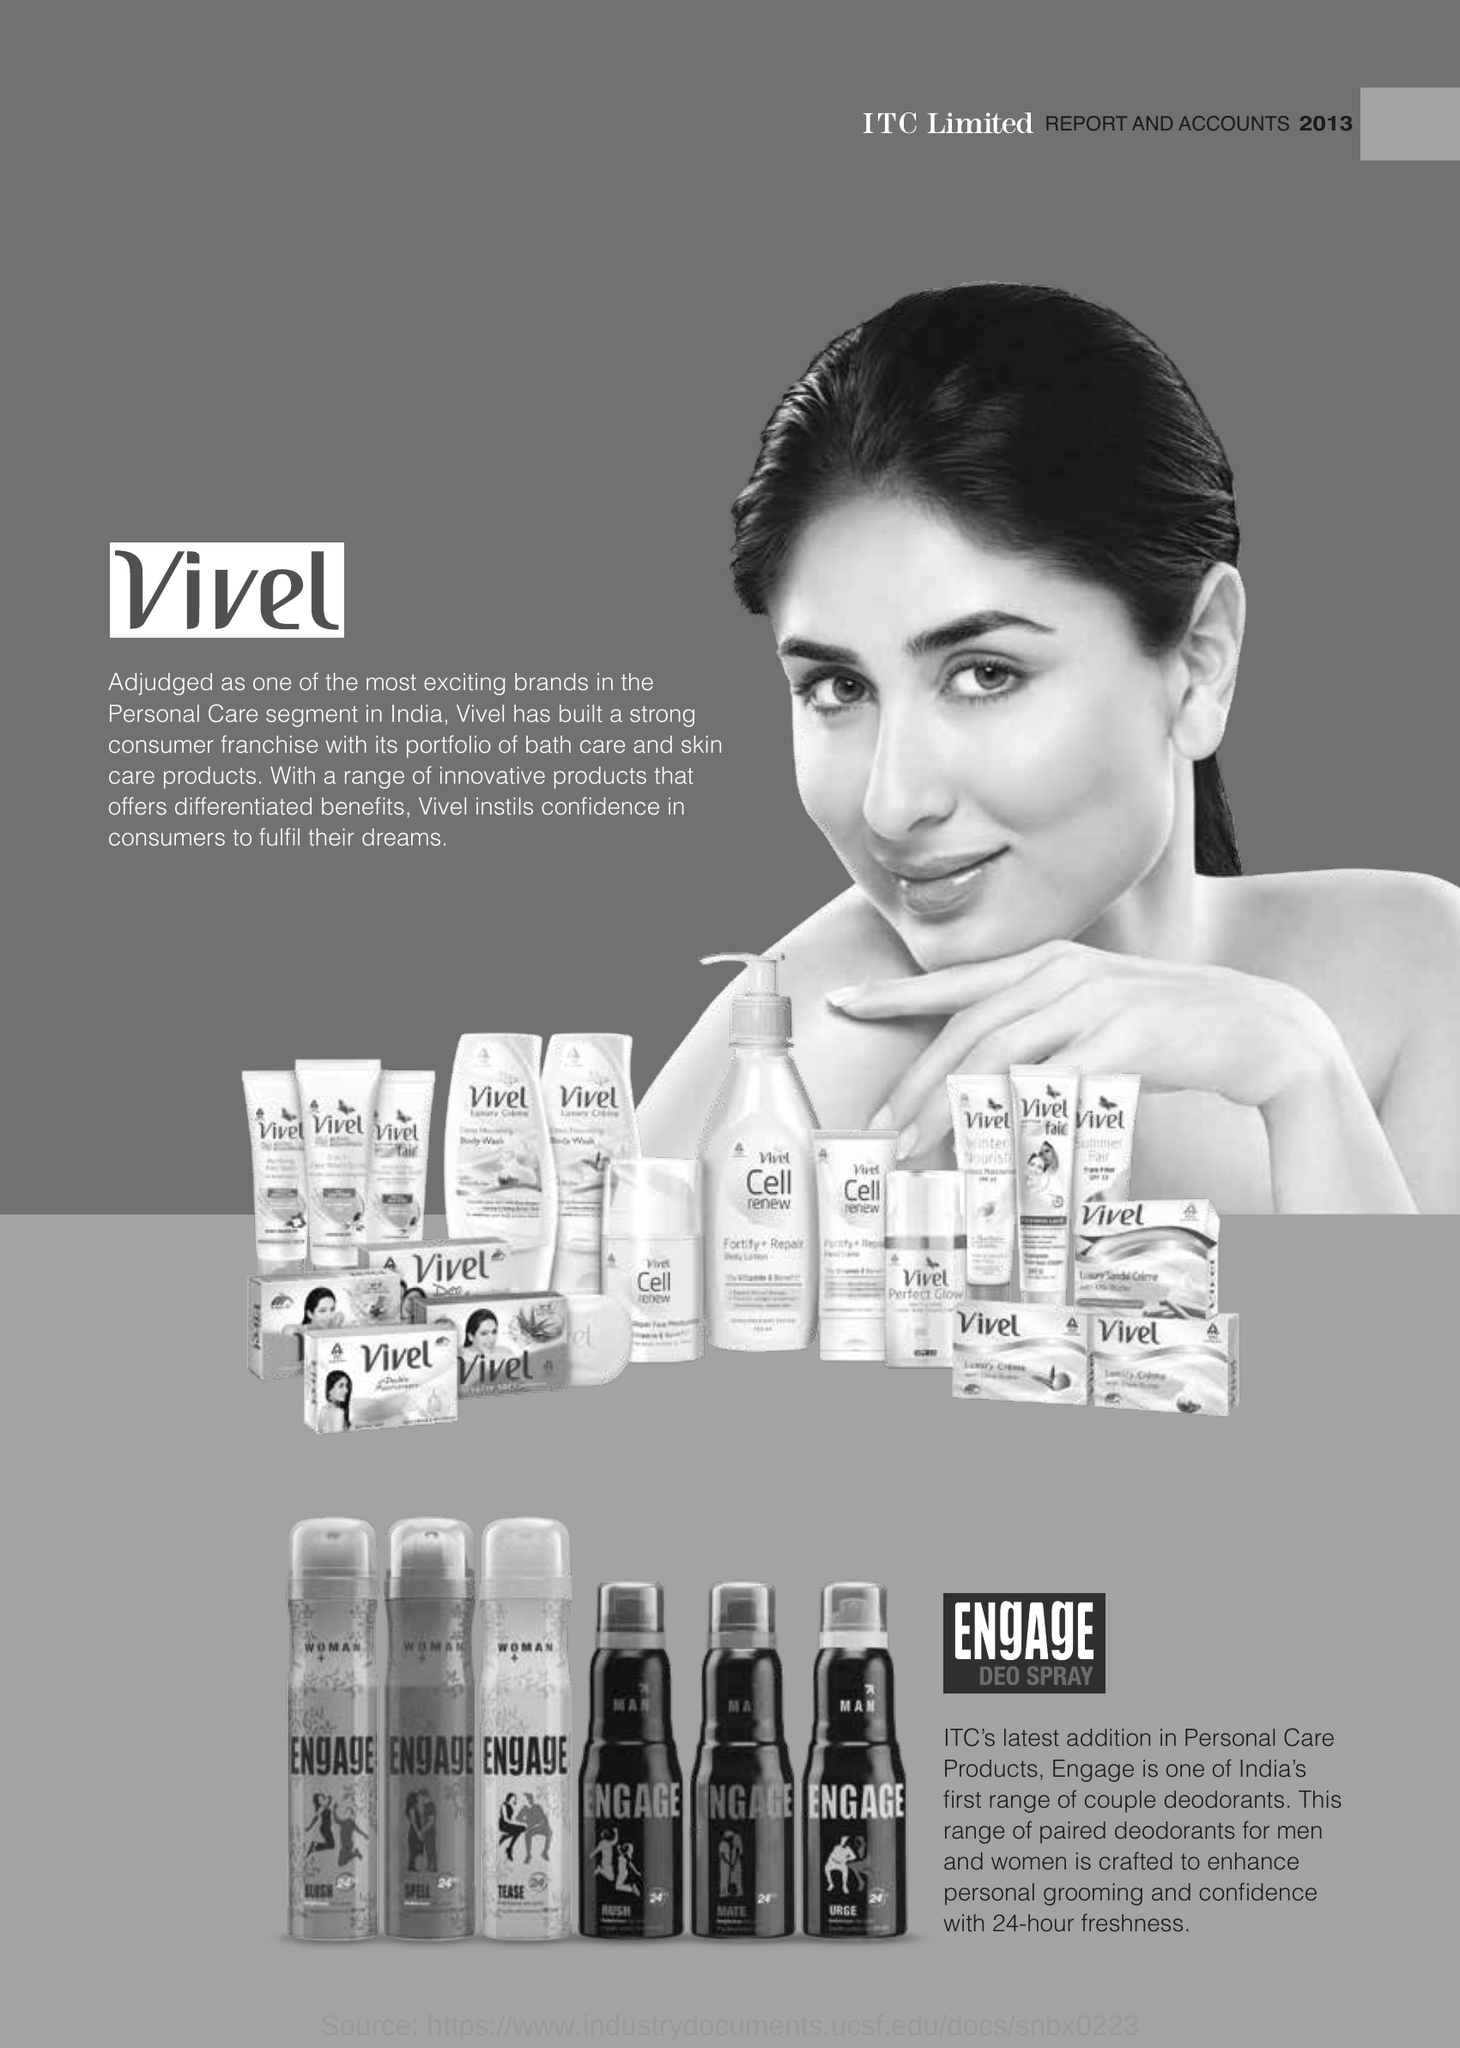What is india's first range of couple deodorants?
Offer a very short reply. Engage. What is adjudged as one of the most exciting bands in the personal care segment in India ?
Offer a very short reply. Vivel. How many hours of freshness does 'Engage' offer ?
Give a very brief answer. 24-hour freshness. 